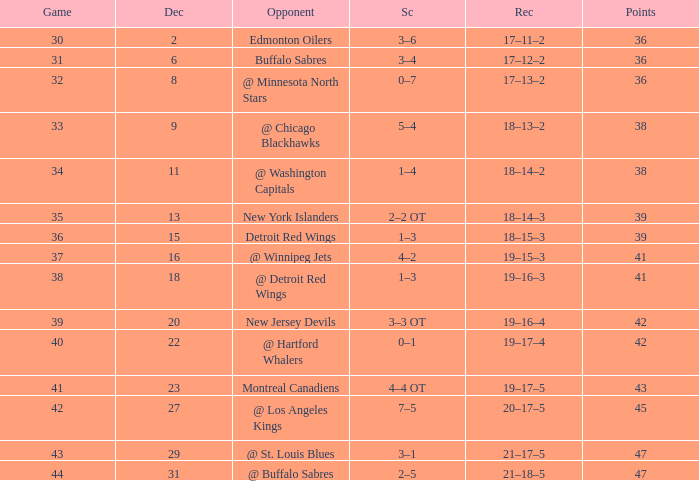After december 29 what is the score? 2–5. 